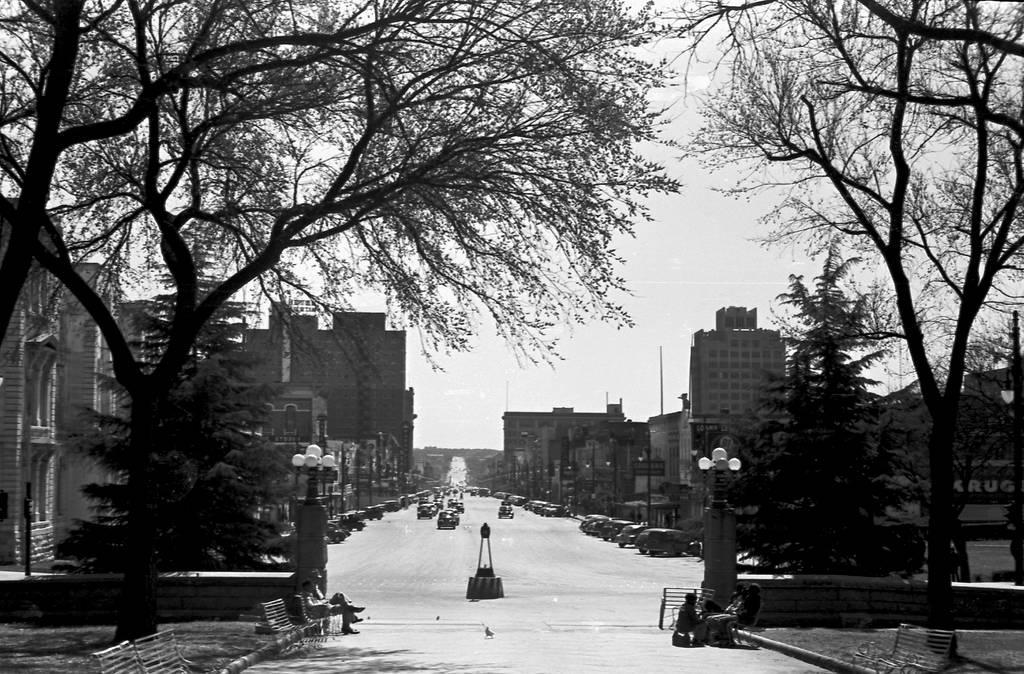Could you give a brief overview of what you see in this image? On the left side, there are benches, persons sitting on a bench, a tree and grass on the ground, there are lights attached to the pole and there are buildings. In the middle of the image, there are vehicles on the road. On the right side, there are a tree and grass on the ground, there are buildings and there is a tree. In the background, there is the sky. 